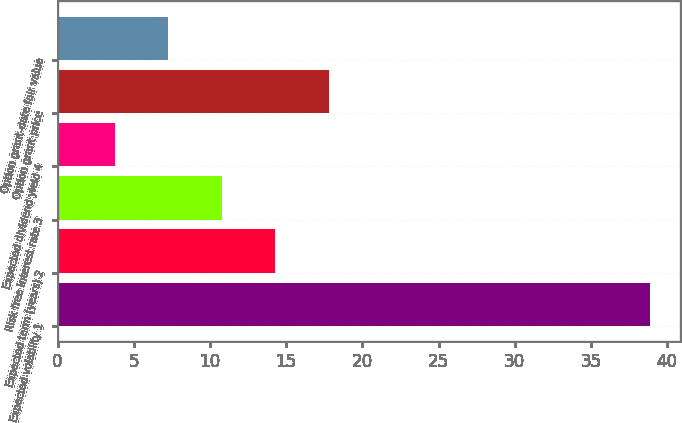Convert chart to OTSL. <chart><loc_0><loc_0><loc_500><loc_500><bar_chart><fcel>Expected volatility 1<fcel>Expected term (years) 2<fcel>Risk free interest rate 3<fcel>Expected dividend yield 4<fcel>Option grant price<fcel>Option grant-date fair value<nl><fcel>38.9<fcel>14.3<fcel>10.79<fcel>3.77<fcel>17.81<fcel>7.28<nl></chart> 